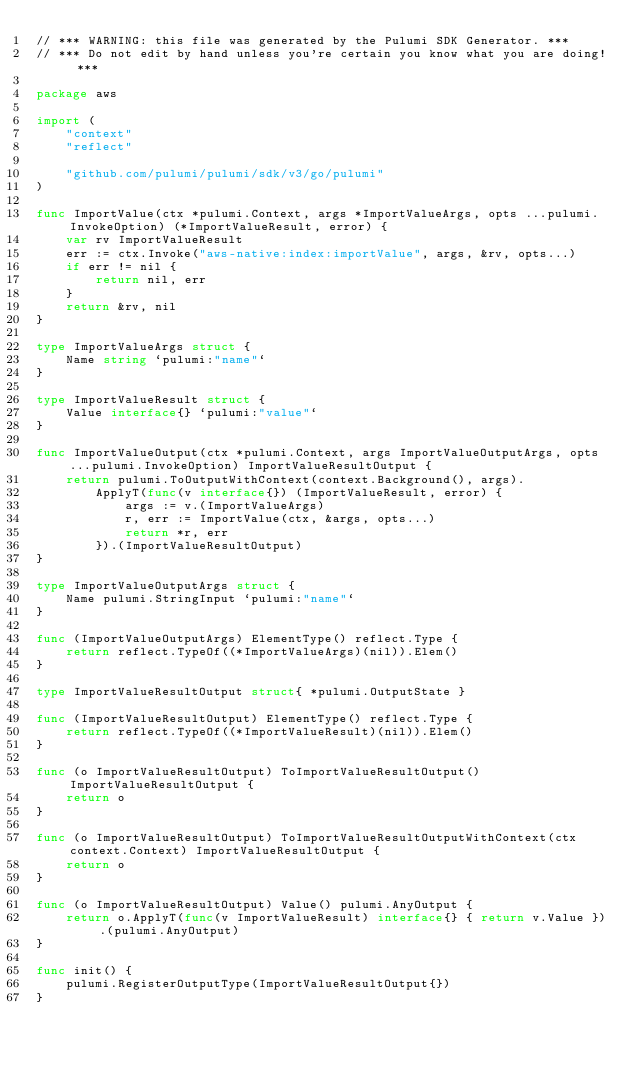<code> <loc_0><loc_0><loc_500><loc_500><_Go_>// *** WARNING: this file was generated by the Pulumi SDK Generator. ***
// *** Do not edit by hand unless you're certain you know what you are doing! ***

package aws

import (
	"context"
	"reflect"

	"github.com/pulumi/pulumi/sdk/v3/go/pulumi"
)

func ImportValue(ctx *pulumi.Context, args *ImportValueArgs, opts ...pulumi.InvokeOption) (*ImportValueResult, error) {
	var rv ImportValueResult
	err := ctx.Invoke("aws-native:index:importValue", args, &rv, opts...)
	if err != nil {
		return nil, err
	}
	return &rv, nil
}

type ImportValueArgs struct {
	Name string `pulumi:"name"`
}

type ImportValueResult struct {
	Value interface{} `pulumi:"value"`
}

func ImportValueOutput(ctx *pulumi.Context, args ImportValueOutputArgs, opts ...pulumi.InvokeOption) ImportValueResultOutput {
	return pulumi.ToOutputWithContext(context.Background(), args).
		ApplyT(func(v interface{}) (ImportValueResult, error) {
			args := v.(ImportValueArgs)
			r, err := ImportValue(ctx, &args, opts...)
			return *r, err
		}).(ImportValueResultOutput)
}

type ImportValueOutputArgs struct {
	Name pulumi.StringInput `pulumi:"name"`
}

func (ImportValueOutputArgs) ElementType() reflect.Type {
	return reflect.TypeOf((*ImportValueArgs)(nil)).Elem()
}

type ImportValueResultOutput struct{ *pulumi.OutputState }

func (ImportValueResultOutput) ElementType() reflect.Type {
	return reflect.TypeOf((*ImportValueResult)(nil)).Elem()
}

func (o ImportValueResultOutput) ToImportValueResultOutput() ImportValueResultOutput {
	return o
}

func (o ImportValueResultOutput) ToImportValueResultOutputWithContext(ctx context.Context) ImportValueResultOutput {
	return o
}

func (o ImportValueResultOutput) Value() pulumi.AnyOutput {
	return o.ApplyT(func(v ImportValueResult) interface{} { return v.Value }).(pulumi.AnyOutput)
}

func init() {
	pulumi.RegisterOutputType(ImportValueResultOutput{})
}
</code> 